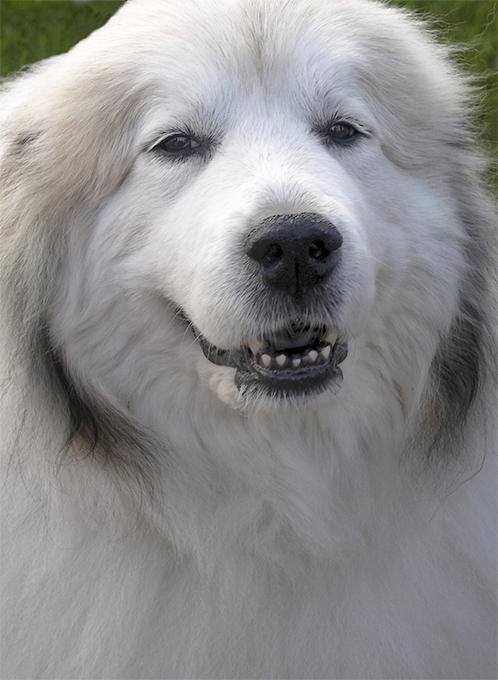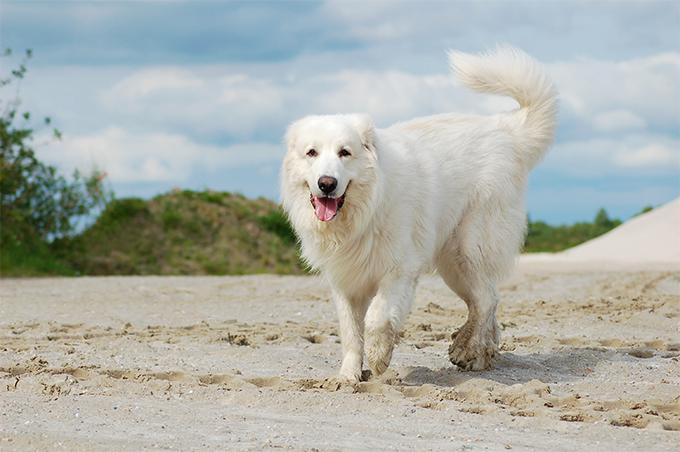The first image is the image on the left, the second image is the image on the right. Considering the images on both sides, is "The image on the left contains only the dog's head and chest." valid? Answer yes or no. Yes. The first image is the image on the left, the second image is the image on the right. For the images displayed, is the sentence "The dog on the right is standing in the grass." factually correct? Answer yes or no. No. The first image is the image on the left, the second image is the image on the right. Considering the images on both sides, is "A large white dog, standing at an outdoor location, has its mouth open and is showing its tongue." valid? Answer yes or no. Yes. 